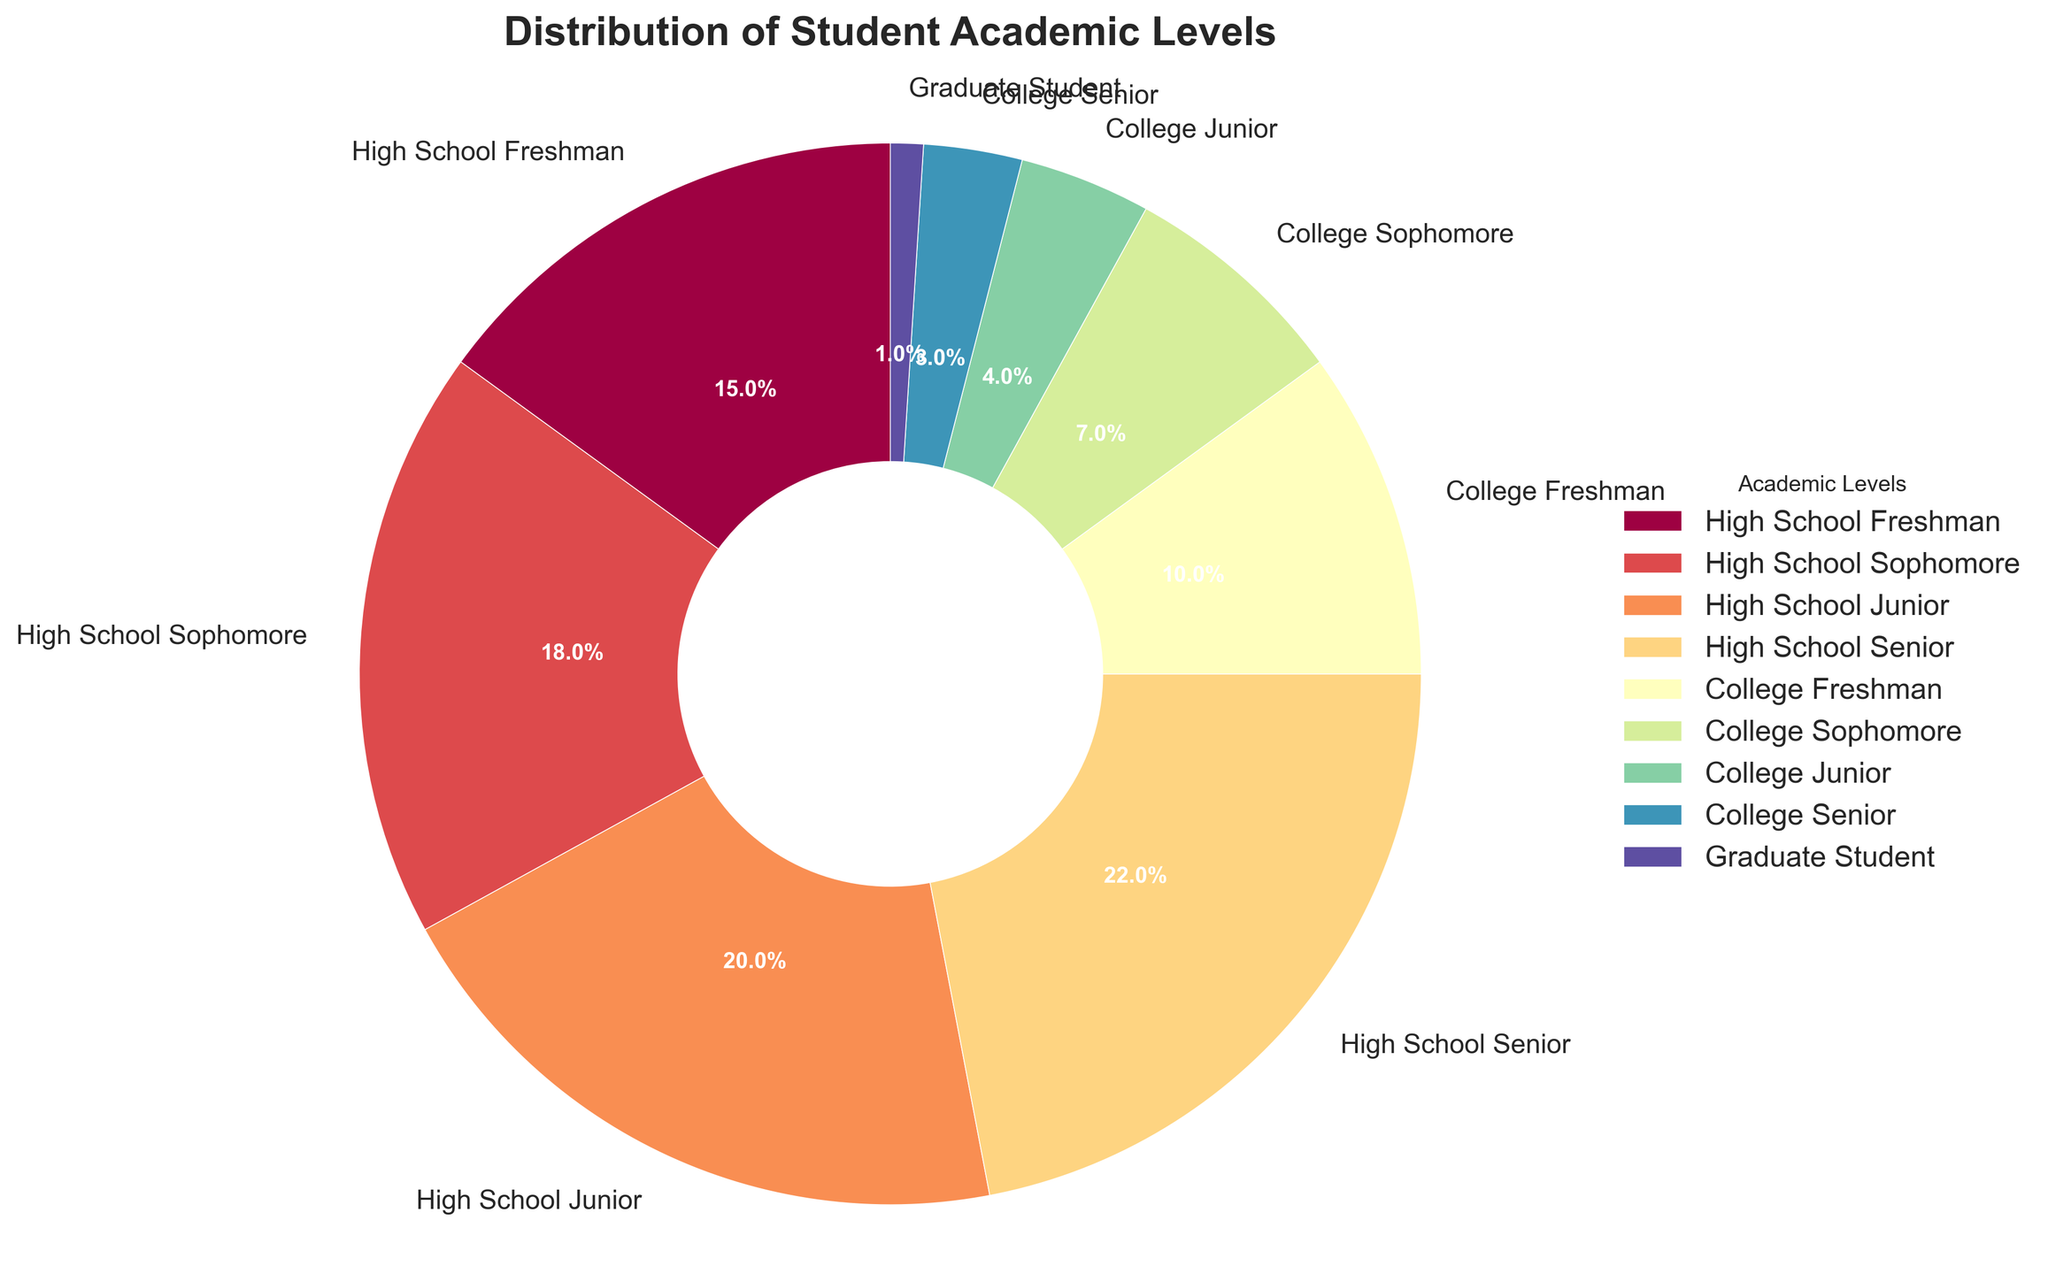What's the largest group of students in the forum? To find the largest group, we look at the segment with the highest percentage. High School Seniors make up 22%, which is the largest section.
Answer: High School Seniors Which academic level has the smallest percentage? From the pie chart, the segment with the smallest percentage is Graduate Students at 1%.
Answer: Graduate Students What's the combined percentage of High School Juniors and High School Seniors? Add the percentages of High School Juniors (20%) and High School Seniors (22%). This equals 20% + 22% = 42%.
Answer: 42% How many times larger is the High School Junior group compared to the College Senior group? The percentage of High School Juniors is 20%, and the percentage of College Seniors is 3%. To find how many times larger, divide 20% by 3%, which is approximately 6.67 times.
Answer: Approximately 6.67 times Is the percentage of High School Freshmen greater than the combined percentage of College Juniors and Seniors? The percentage of High School Freshmen is 15%. The combined percentage of College Juniors (4%) and College Seniors (3%) is 4% + 3% = 7%. 15% is greater than 7%.
Answer: Yes What's the total percentage of all high school students? Add the percentages of all high school students: High School Freshman (15%), Sophomore (18%), Junior (20%), and Senior (22%). This equals 15% + 18% + 20% + 22% = 75%.
Answer: 75% What percentage of the students are either College Freshmen or College Sophomores? Add the percentages of College Freshmen (10%) and College Sophomores (7%). This equals 10% + 7% = 17%.
Answer: 17% Which academic level group uses the darkest color in the pie chart? The color gradient typically starts from light to dark in a spectral color map. Graduate Students have the smallest percentage and are likely to be the darkest color as they are the last on the list.
Answer: Graduate Students If you merge all college student groups together, how does their total percentage compare to that of High School Juniors alone? Combine the percentages of College Freshman (10%), Sophomore (7%), Junior (4%), and Senior (3%): 10% + 7% + 4% + 3% = 24%. Compare this to High School Juniors, which is 20%. 24% is greater than 20%.
Answer: College group: 24%, which is greater than 20% What's the difference in percentage between High School Sophomores and College Sophomores? Subtract the percentage of College Sophomores (7%) from High School Sophomores (18%). This equals 18% - 7% = 11%.
Answer: 11% 